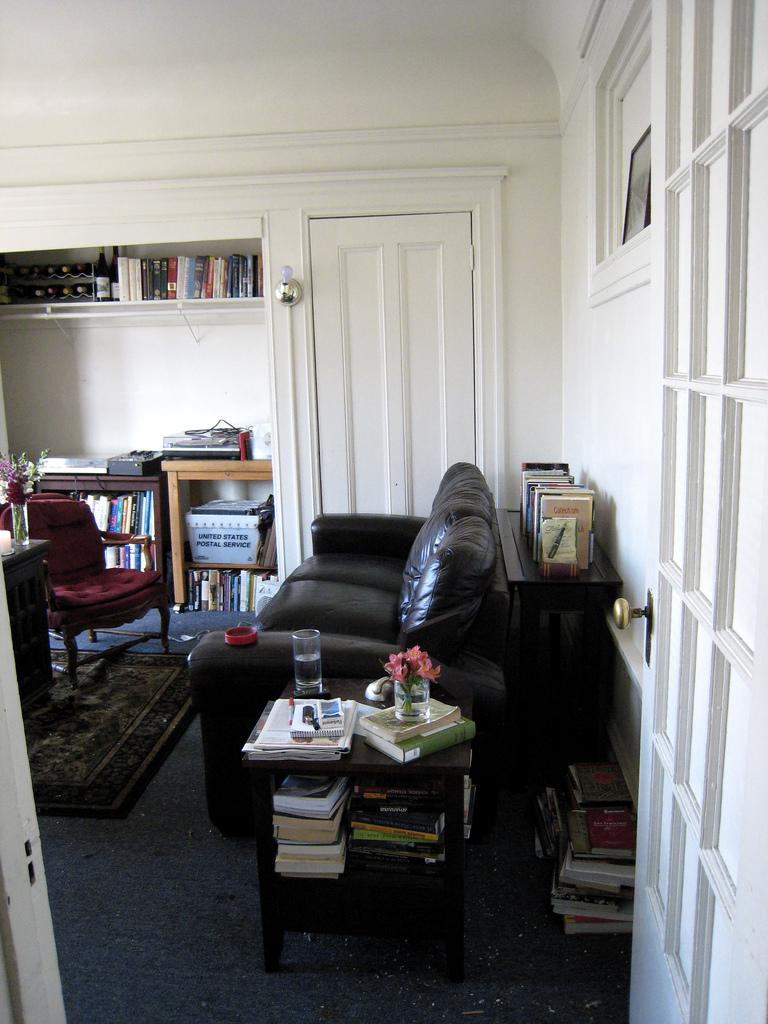Question: what other beverage than water do you see in the room?
Choices:
A. Wine.
B. Beer.
C. Soda.
D. Juice.
Answer with the letter. Answer: A Question: how many vases of water are in the room?
Choices:
A. Two.
B. Three.
C. One.
D. None.
Answer with the letter. Answer: A Question: where was this photo taken?
Choices:
A. In a living room.
B. In my car.
C. On the airplane.
D. At the recital.
Answer with the letter. Answer: A Question: what is in the room?
Choices:
A. Movies, games, and a chair.
B. Books, magazines, and a couch.
C. Cocktails, appetizers, and a fireplace.
D. Darts, beer, and a pool table.
Answer with the letter. Answer: B Question: what is on the shelf?
Choices:
A. A case.
B. A chest.
C. A box.
D. A crate.
Answer with the letter. Answer: D Question: what is on the floor?
Choices:
A. A rug.
B. A carpet.
C. A mat.
D. A tapestry.
Answer with the letter. Answer: A Question: what is on the table?
Choices:
A. A mug.
B. A goblet.
C. A glass.
D. A tumbler.
Answer with the letter. Answer: C Question: what is white?
Choices:
A. Door.
B. House.
C. Barn.
D. Car.
Answer with the letter. Answer: A Question: what is plastic?
Choices:
A. Container.
B. Bottle.
C. Cup.
D. Ball.
Answer with the letter. Answer: A Question: what is white?
Choices:
A. Car.
B. Hair.
C. Walls.
D. Cat.
Answer with the letter. Answer: C Question: where are the books?
Choices:
A. Behind the couch.
B. On the shelf.
C. On the table.
D. In a box.
Answer with the letter. Answer: A Question: where is the record player?
Choices:
A. In the closet.
B. In the room.
C. On a wooden table.
D. In the basement.
Answer with the letter. Answer: C Question: what can be seen?
Choices:
A. Many books.
B. Nothing.
C. The crowd.
D. The band.
Answer with the letter. Answer: A 